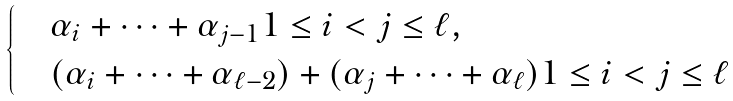<formula> <loc_0><loc_0><loc_500><loc_500>\begin{cases} & \alpha _ { i } + \dots + \alpha _ { j - 1 } 1 \leq i < j \leq \ell , \quad \\ & ( \alpha _ { i } + \dots + \alpha _ { \ell - 2 } ) + ( \alpha _ { j } + \dots + \alpha _ { \ell } ) 1 \leq i < j \leq \ell \end{cases}</formula> 